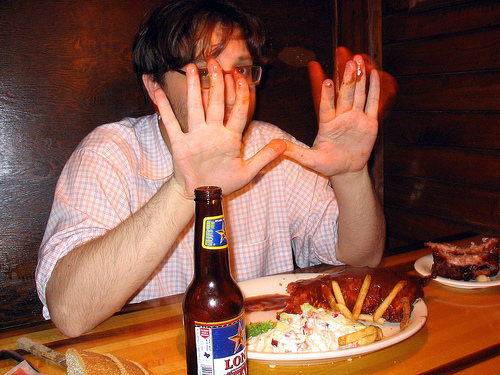<image>
Is there a knife under the bread? Yes. The knife is positioned underneath the bread, with the bread above it in the vertical space. Where is the food in relation to the man? Is it in front of the man? Yes. The food is positioned in front of the man, appearing closer to the camera viewpoint. 